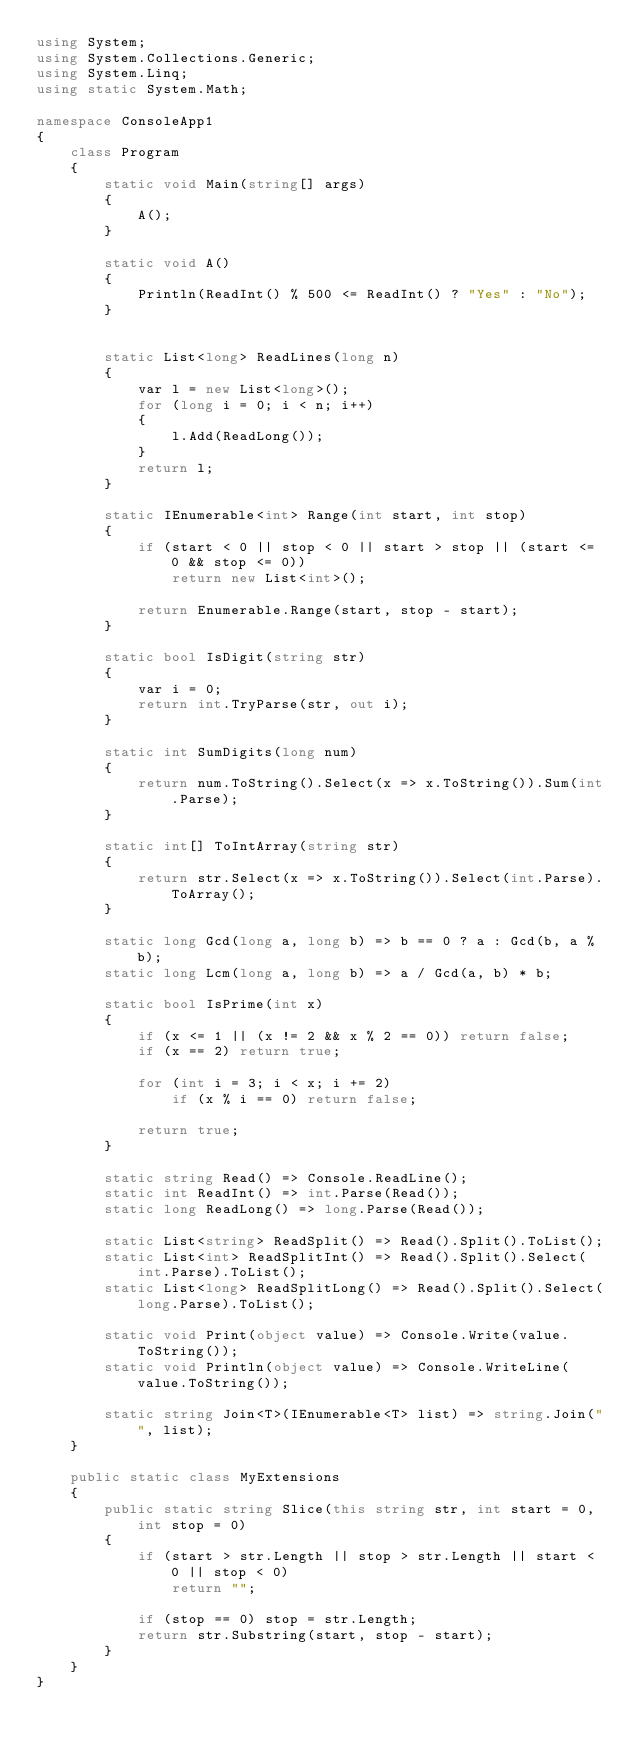Convert code to text. <code><loc_0><loc_0><loc_500><loc_500><_C#_>using System;
using System.Collections.Generic;
using System.Linq;
using static System.Math;

namespace ConsoleApp1
{
    class Program
    {
        static void Main(string[] args)
        {
            A();
        }

        static void A()
        {
            Println(ReadInt() % 500 <= ReadInt() ? "Yes" : "No");
        }


        static List<long> ReadLines(long n)
        {
            var l = new List<long>();
            for (long i = 0; i < n; i++)
            {
                l.Add(ReadLong());
            }
            return l;
        }

        static IEnumerable<int> Range(int start, int stop)
        {
            if (start < 0 || stop < 0 || start > stop || (start <= 0 && stop <= 0))
                return new List<int>();

            return Enumerable.Range(start, stop - start);
        }

        static bool IsDigit(string str)
        {
            var i = 0;
            return int.TryParse(str, out i);
        }

        static int SumDigits(long num)
        {
            return num.ToString().Select(x => x.ToString()).Sum(int.Parse);
        }

        static int[] ToIntArray(string str)
        {
            return str.Select(x => x.ToString()).Select(int.Parse).ToArray();
        }

        static long Gcd(long a, long b) => b == 0 ? a : Gcd(b, a % b);
        static long Lcm(long a, long b) => a / Gcd(a, b) * b;

        static bool IsPrime(int x)
        {
            if (x <= 1 || (x != 2 && x % 2 == 0)) return false;
            if (x == 2) return true;

            for (int i = 3; i < x; i += 2)
                if (x % i == 0) return false;

            return true;
        }

        static string Read() => Console.ReadLine();
        static int ReadInt() => int.Parse(Read());
        static long ReadLong() => long.Parse(Read());

        static List<string> ReadSplit() => Read().Split().ToList();
        static List<int> ReadSplitInt() => Read().Split().Select(int.Parse).ToList();
        static List<long> ReadSplitLong() => Read().Split().Select(long.Parse).ToList();

        static void Print(object value) => Console.Write(value.ToString());
        static void Println(object value) => Console.WriteLine(value.ToString());

        static string Join<T>(IEnumerable<T> list) => string.Join("", list);
    }

    public static class MyExtensions
    {
        public static string Slice(this string str, int start = 0, int stop = 0)
        {
            if (start > str.Length || stop > str.Length || start < 0 || stop < 0)
                return "";

            if (stop == 0) stop = str.Length;
            return str.Substring(start, stop - start);
        }
    }
}
</code> 